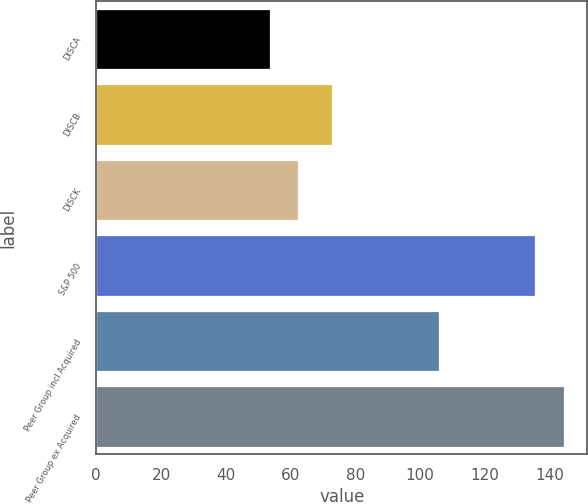Convert chart to OTSL. <chart><loc_0><loc_0><loc_500><loc_500><bar_chart><fcel>DISCA<fcel>DISCB<fcel>DISCK<fcel>S&P 500<fcel>Peer Group incl Acquired<fcel>Peer Group ex Acquired<nl><fcel>53.56<fcel>72.9<fcel>62.36<fcel>135.63<fcel>105.8<fcel>144.43<nl></chart> 